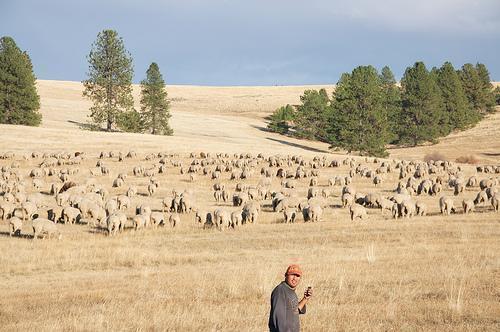How many men are there?
Give a very brief answer. 1. How many people are visible?
Give a very brief answer. 1. 